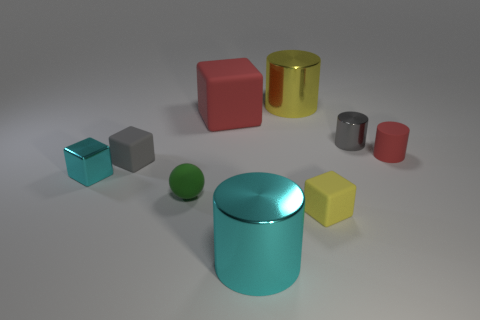Subtract all tiny cyan cubes. How many cubes are left? 3 Subtract all red cylinders. How many cylinders are left? 3 Subtract 2 cylinders. How many cylinders are left? 2 Subtract all cubes. How many objects are left? 5 Subtract 1 cyan blocks. How many objects are left? 8 Subtract all red balls. Subtract all cyan cylinders. How many balls are left? 1 Subtract all purple cylinders. How many gray cubes are left? 1 Subtract all big yellow metallic objects. Subtract all yellow metallic cylinders. How many objects are left? 7 Add 1 big yellow shiny objects. How many big yellow shiny objects are left? 2 Add 6 gray metallic blocks. How many gray metallic blocks exist? 6 